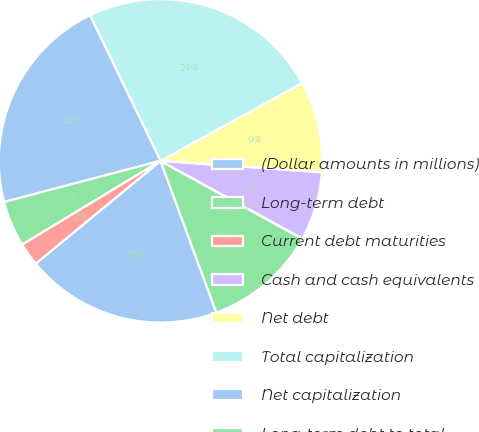Convert chart. <chart><loc_0><loc_0><loc_500><loc_500><pie_chart><fcel>(Dollar amounts in millions)<fcel>Long-term debt<fcel>Current debt maturities<fcel>Cash and cash equivalents<fcel>Net debt<fcel>Total capitalization<fcel>Net capitalization<fcel>Long-term debt to total<fcel>Net debt to net capitalization<nl><fcel>19.64%<fcel>11.39%<fcel>0.03%<fcel>6.85%<fcel>9.12%<fcel>24.19%<fcel>21.91%<fcel>4.57%<fcel>2.3%<nl></chart> 